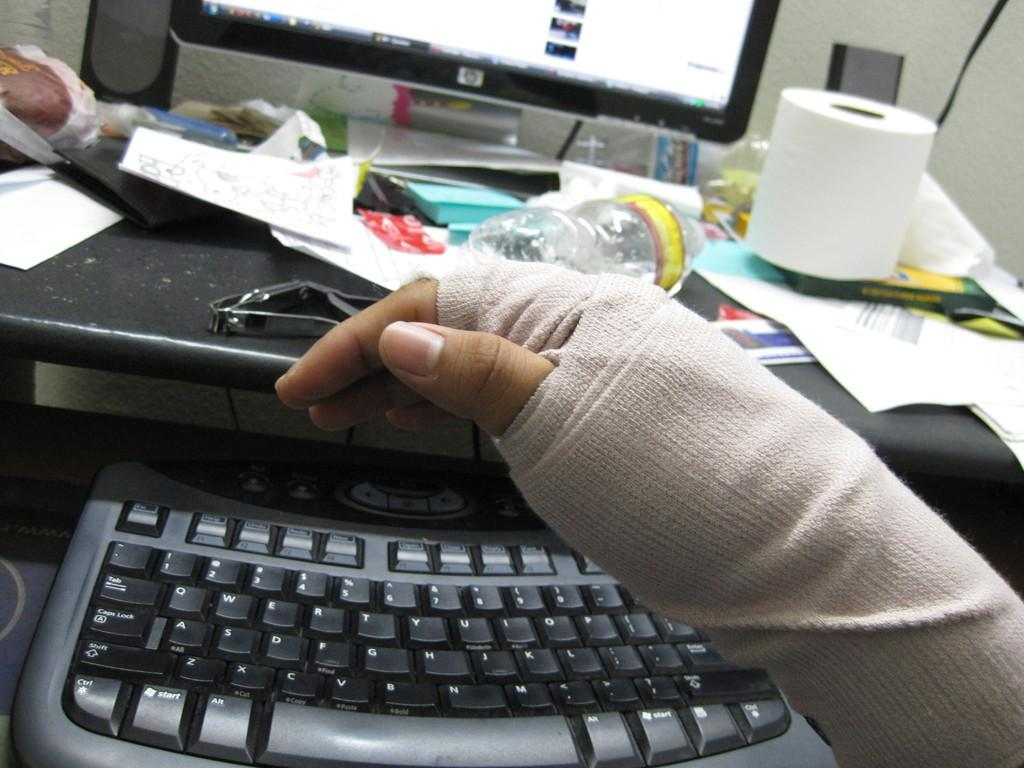<image>
Summarize the visual content of the image. a bandaged hand in front of an HP computer monitor 